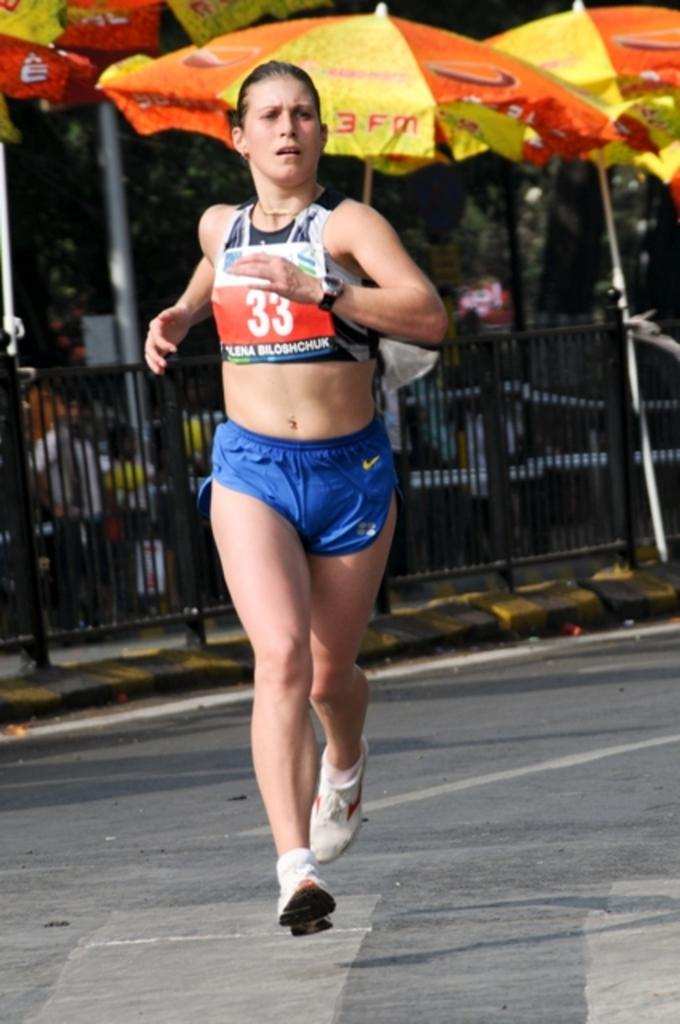<image>
Create a compact narrative representing the image presented. Runner number 33 has her hair tied back and is wearing a watch. 